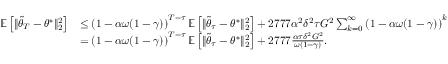Convert formula to latex. <formula><loc_0><loc_0><loc_500><loc_500>\begin{array} { r l } { \mathbb { E } \left [ \| \tilde { \theta } _ { T } - \theta ^ { * } \| _ { 2 } ^ { 2 } \right ] } & { \leq \left ( 1 - \alpha \omega ( 1 - \gamma ) \right ) ^ { T - \tau } \mathbb { E } \left [ \| \tilde { \theta } _ { \tau } - \theta ^ { * } \| _ { 2 } ^ { 2 } \right ] + 2 7 7 7 \alpha ^ { 2 } \delta ^ { 2 } \tau G ^ { 2 } \sum _ { k = 0 } ^ { \infty } \left ( 1 - \alpha \omega ( 1 - \gamma ) \right ) ^ { k } } \\ & { = \left ( 1 - \alpha \omega ( 1 - \gamma ) \right ) ^ { T - \tau } \mathbb { E } \left [ \| \tilde { \theta } _ { \tau } - \theta ^ { * } \| _ { 2 } ^ { 2 } \right ] + 2 7 7 7 \frac { \alpha \tau \delta ^ { 2 } G ^ { 2 } } { \omega ( 1 - \gamma ) } . } \end{array}</formula> 